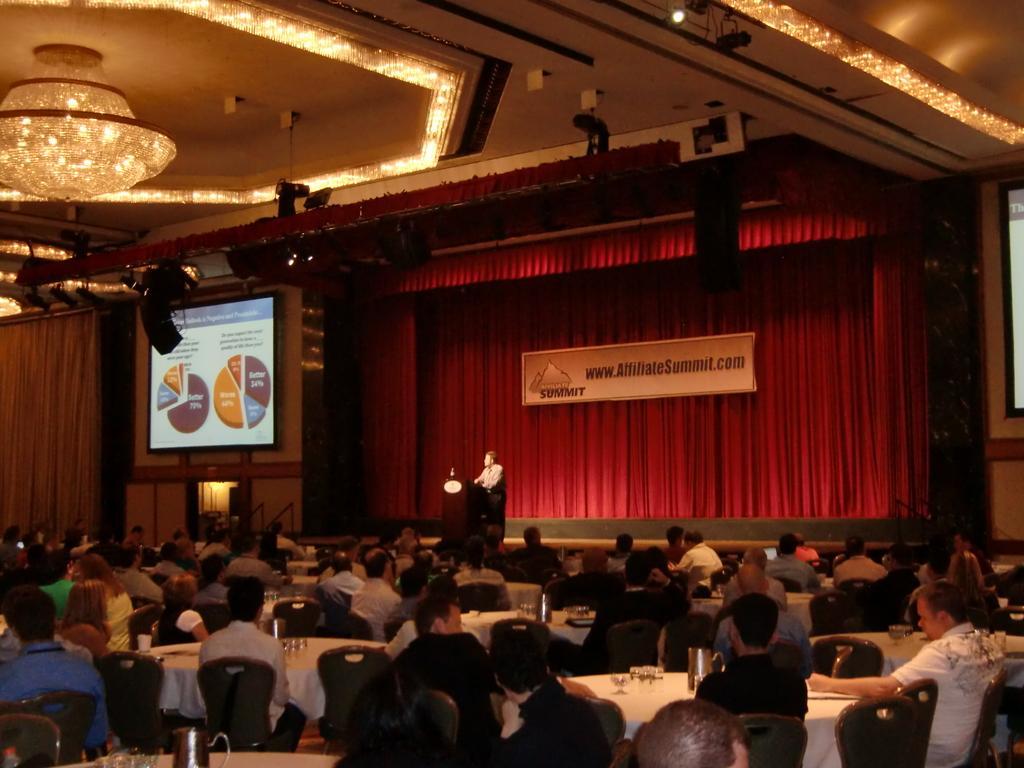In one or two sentences, can you explain what this image depicts? In this image I can see the group of people are sitting on the chairs. I can see few water jars and few objects on the tables. In the background I can see the red color curtains, board, few projection screens, wall and the person is standing in front of the podium. I can see few lights and the chandelier to the ceiling. 